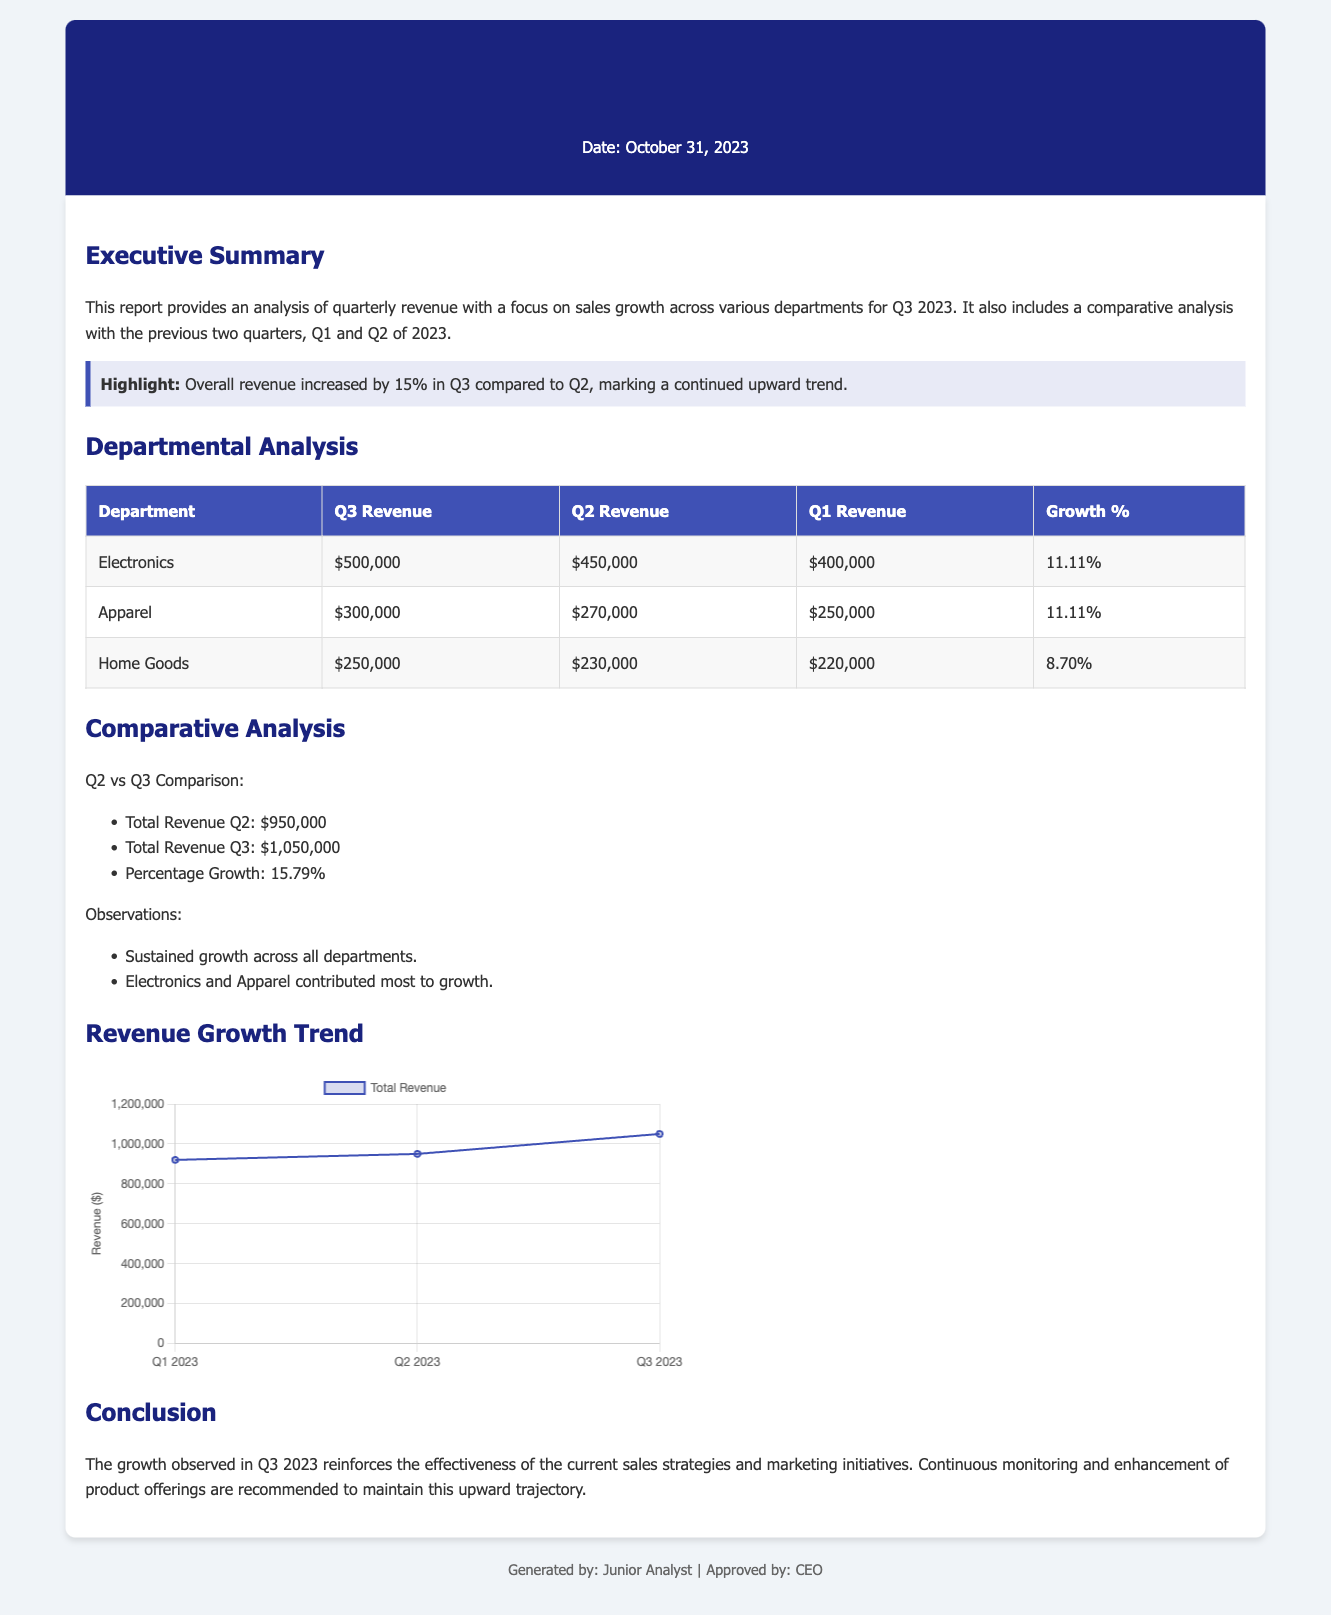What is the total revenue for Q3 2023? The document explicitly states that the total revenue for Q3 2023 is $1,050,000.
Answer: $1,050,000 What was the revenue for Electronics in Q2? According to the table, the revenue for Electronics in Q2 was $450,000.
Answer: $450,000 What is the percentage growth for Apparel from Q2 to Q3? The percentage growth for Apparel is provided in the table as 11.11%.
Answer: 11.11% What is the main highlight of the report? The highlight mentions that overall revenue increased by 15% in Q3 compared to Q2.
Answer: Overall revenue increased by 15% How much did Home Goods earn in Q1? The document lists the revenue for Home Goods in Q1 as $220,000.
Answer: $220,000 Which department contributed the most to growth in Q3? The observations section highlights that Electronics and Apparel contributed most to growth.
Answer: Electronics and Apparel What was the total revenue for Q2? The document states that the total revenue for Q2 was $950,000.
Answer: $950,000 What growth percentage does the document highlight for Q2 compared to Q3? The document details that the percentage growth from Q2 to Q3 is 15.79%.
Answer: 15.79% Who generated this report? The footer of the document indicates that the report was generated by a Junior Analyst.
Answer: Junior Analyst 